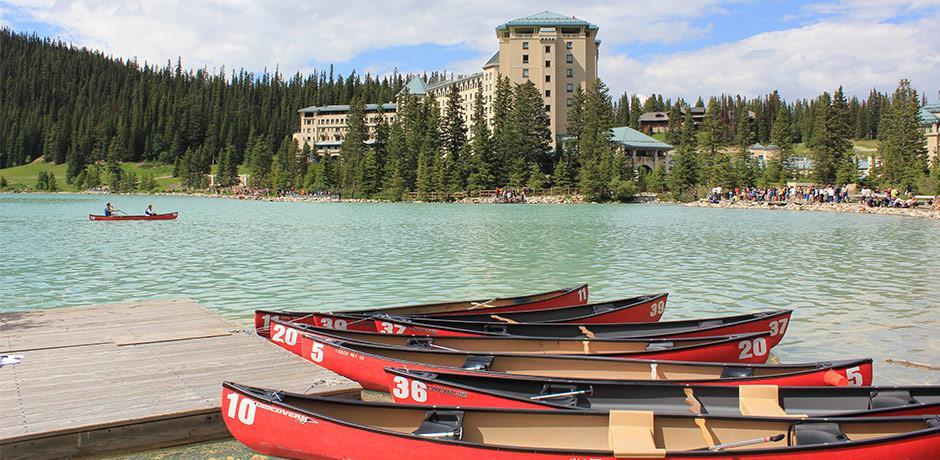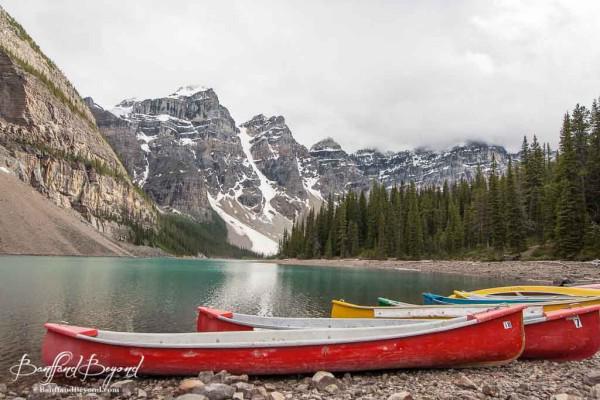The first image is the image on the left, the second image is the image on the right. Analyze the images presented: Is the assertion "One image contains only canoes that are red." valid? Answer yes or no. Yes. 